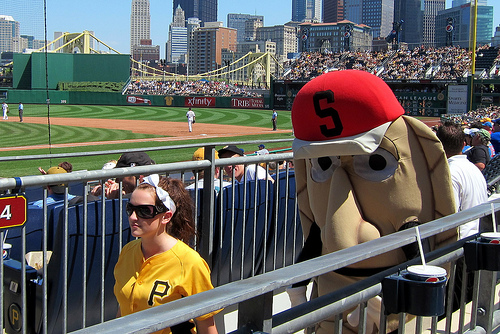<image>
Is there a fence behind the woman? Yes. From this viewpoint, the fence is positioned behind the woman, with the woman partially or fully occluding the fence. 